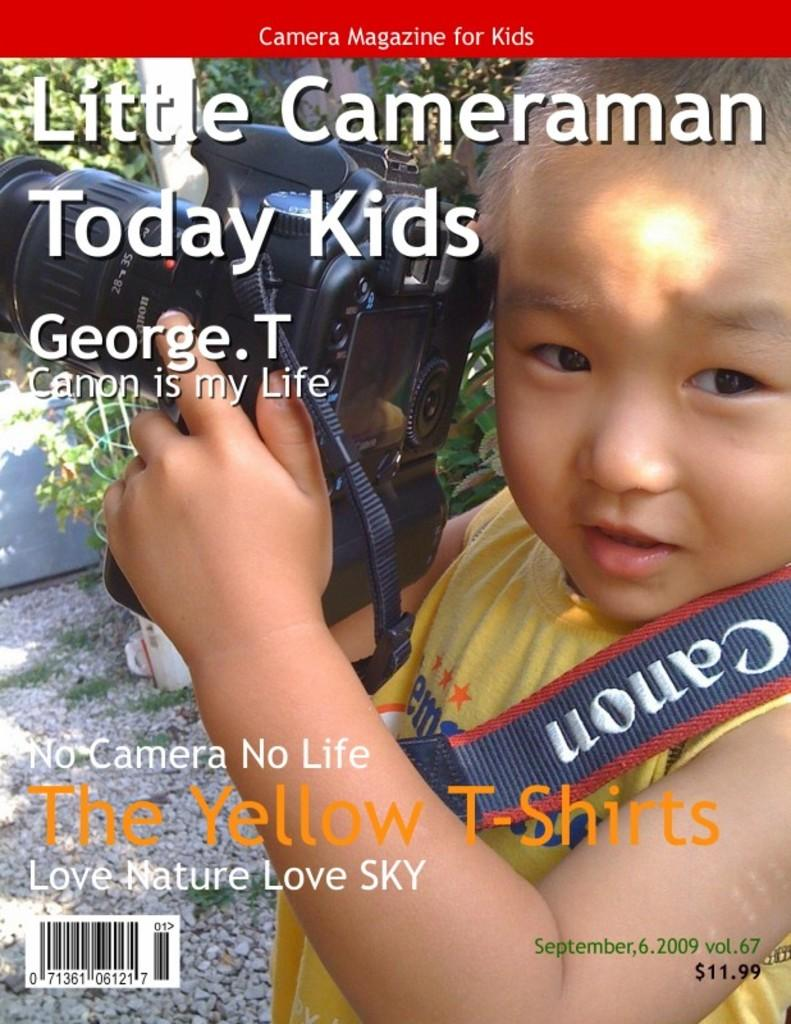What is the main subject of the image? There is a child in the image. What is the child holding in the image? The child is holding a camera. What color combination is the child wearing in the image? The child is wearing a yellow and blue color t-shirt. What can be seen in the background of the image? There are trees visible in the background of the image. What type of pie is the child eating in the image? There is no pie present in the image; the child is holding a camera. How does the child's anger affect the trees in the background of the image? The child's anger is not mentioned in the image, and there is no indication that it affects the trees in the background. 